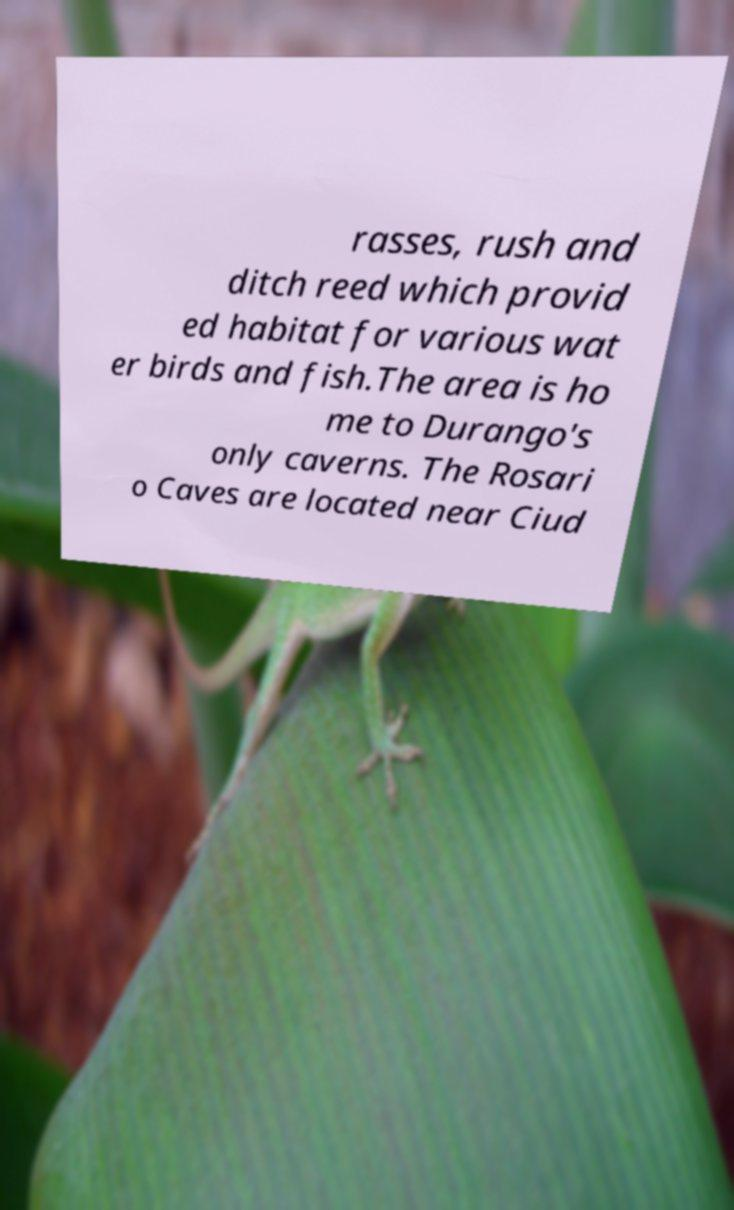Can you read and provide the text displayed in the image?This photo seems to have some interesting text. Can you extract and type it out for me? rasses, rush and ditch reed which provid ed habitat for various wat er birds and fish.The area is ho me to Durango's only caverns. The Rosari o Caves are located near Ciud 